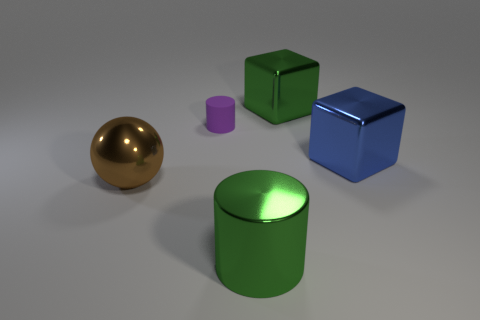Subtract all red blocks. Subtract all green cylinders. How many blocks are left? 2 Add 4 small gray objects. How many objects exist? 9 Subtract all spheres. How many objects are left? 4 Subtract all big purple rubber cylinders. Subtract all metal cubes. How many objects are left? 3 Add 5 big green cylinders. How many big green cylinders are left? 6 Add 4 big yellow matte cylinders. How many big yellow matte cylinders exist? 4 Subtract 1 green blocks. How many objects are left? 4 